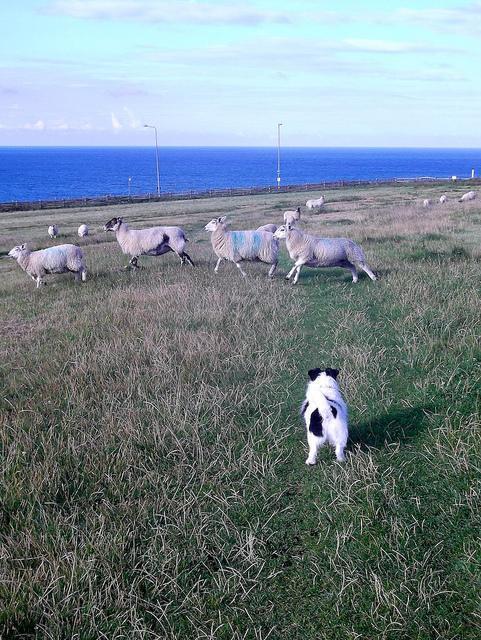What are the blue marks from?
Make your selection and explain in format: 'Answer: answer
Rationale: rationale.'
Options: Paint, crayon, chalk, oil. Answer: paint.
Rationale: Livestock is marked for various reasons such as breeding or illness 